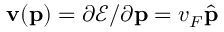<formula> <loc_0><loc_0><loc_500><loc_500>{ v } ( { p } ) = \partial \ m a t h s c r { E } / \partial { p } = v _ { F } \hat { p }</formula> 